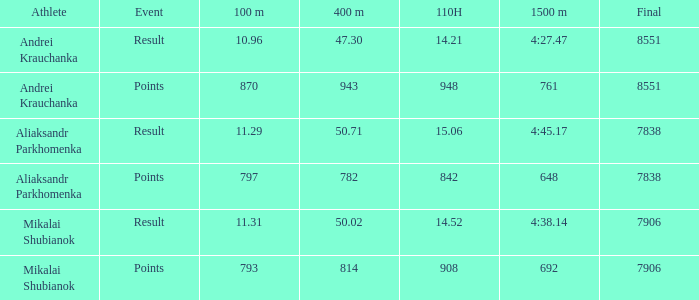3? None. 